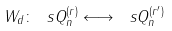<formula> <loc_0><loc_0><loc_500><loc_500>W _ { d } \colon \ s Q _ { n } ^ { ( r ) } \longleftrightarrow \ s Q _ { n } ^ { ( r ^ { \prime } ) }</formula> 